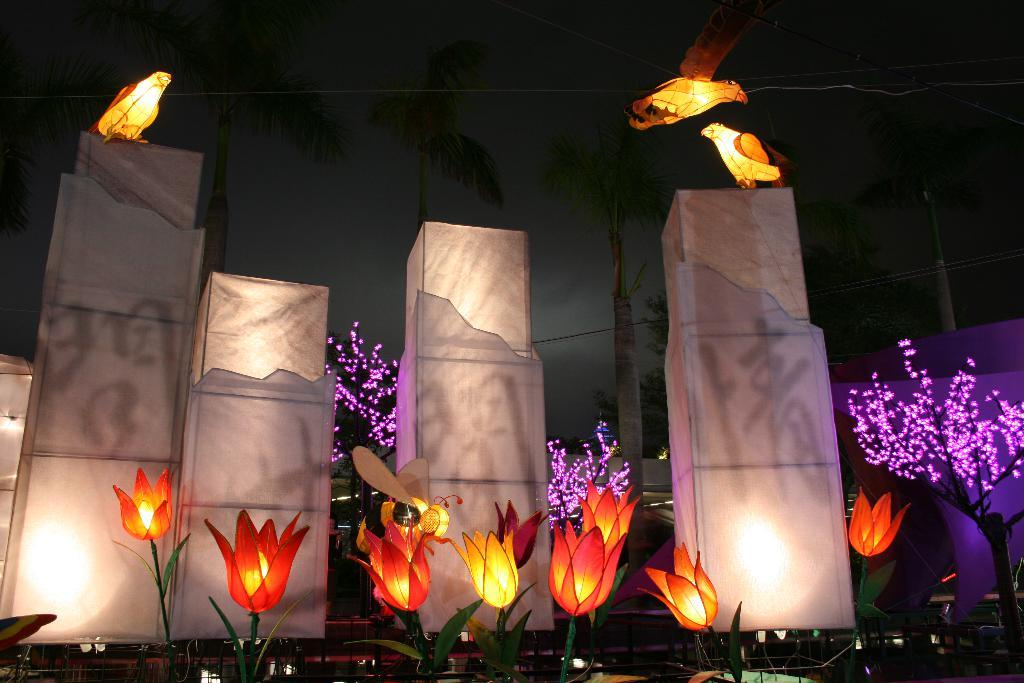What types of decorative items can be seen in the image? There are decorative items in the image. Are there any natural elements present in the image? Yes, there are flowers in the image. What is unique about the pillars in the image? The pillars have birds on them. What can be seen in the background of the image? There are trees in the background of the image. What is the value of the brick in the image? There is no brick present in the image, so it is not possible to determine its value. How many sponges are visible in the image? There are no sponges visible in the image. 